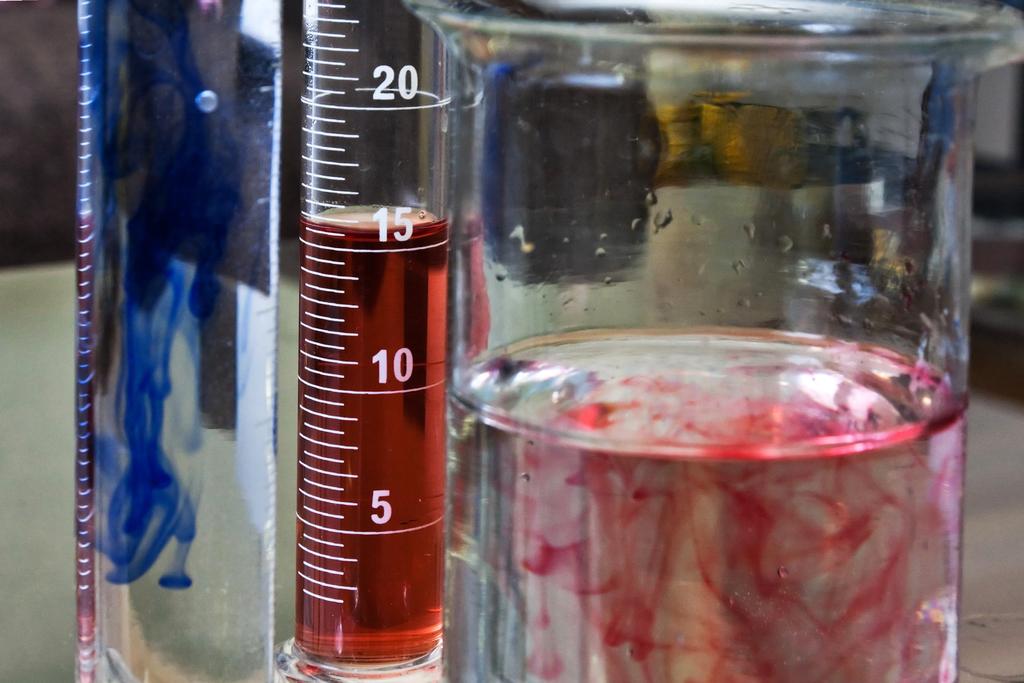What is the number at the top?
Ensure brevity in your answer.  20. What number is the liquid closest too?
Keep it short and to the point. 15. 